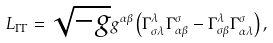Convert formula to latex. <formula><loc_0><loc_0><loc_500><loc_500>L _ { \Gamma \Gamma } = \sqrt { - g } g ^ { \alpha \beta } \left ( \Gamma _ { \sigma \lambda } ^ { \lambda } \Gamma _ { \alpha \beta } ^ { \sigma } - \Gamma _ { \sigma \beta } ^ { \lambda } \Gamma _ { \alpha \lambda } ^ { \sigma } \right ) ,</formula> 